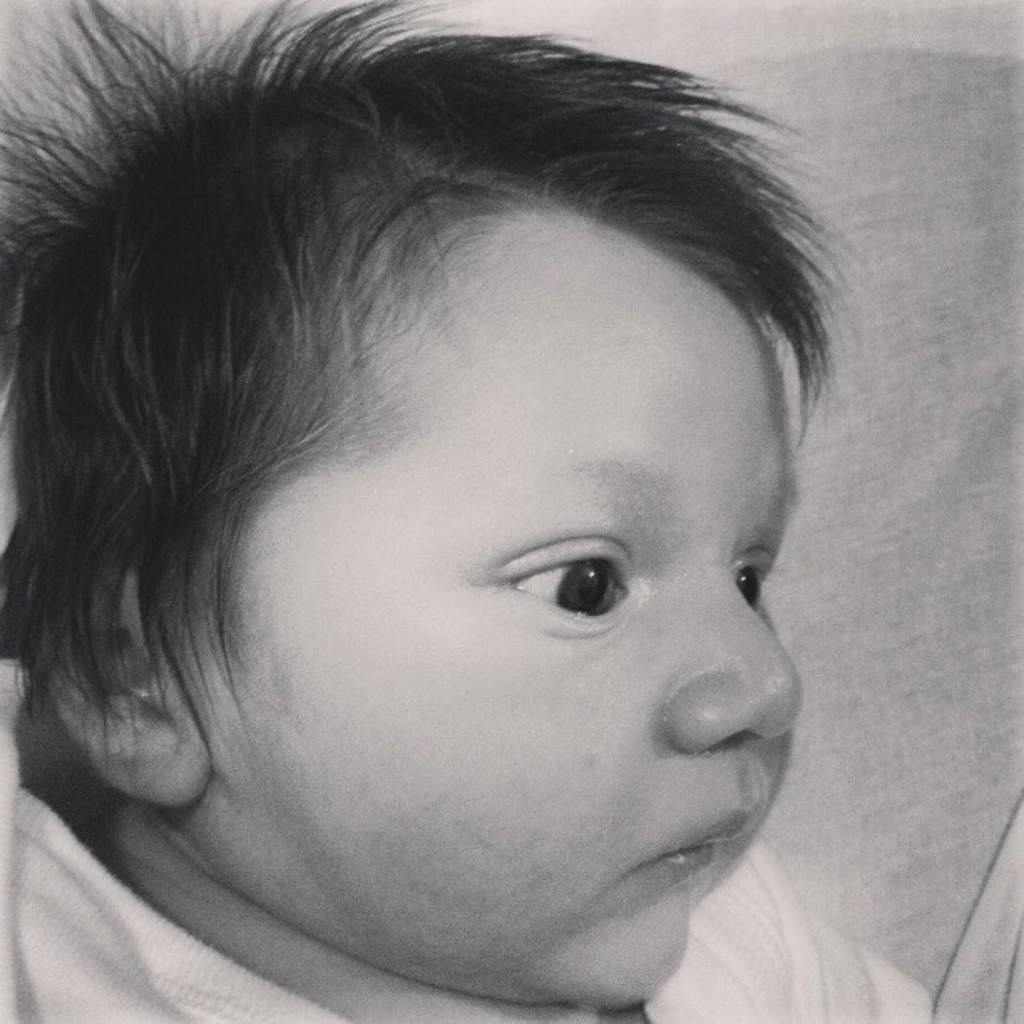Describe this image in one or two sentences. This is a black and white picture. In this picture, we see a baby is wearing a white T-shirt. We can see eyes, ear, nose and mouth of the baby. In the background, it is white in color. 